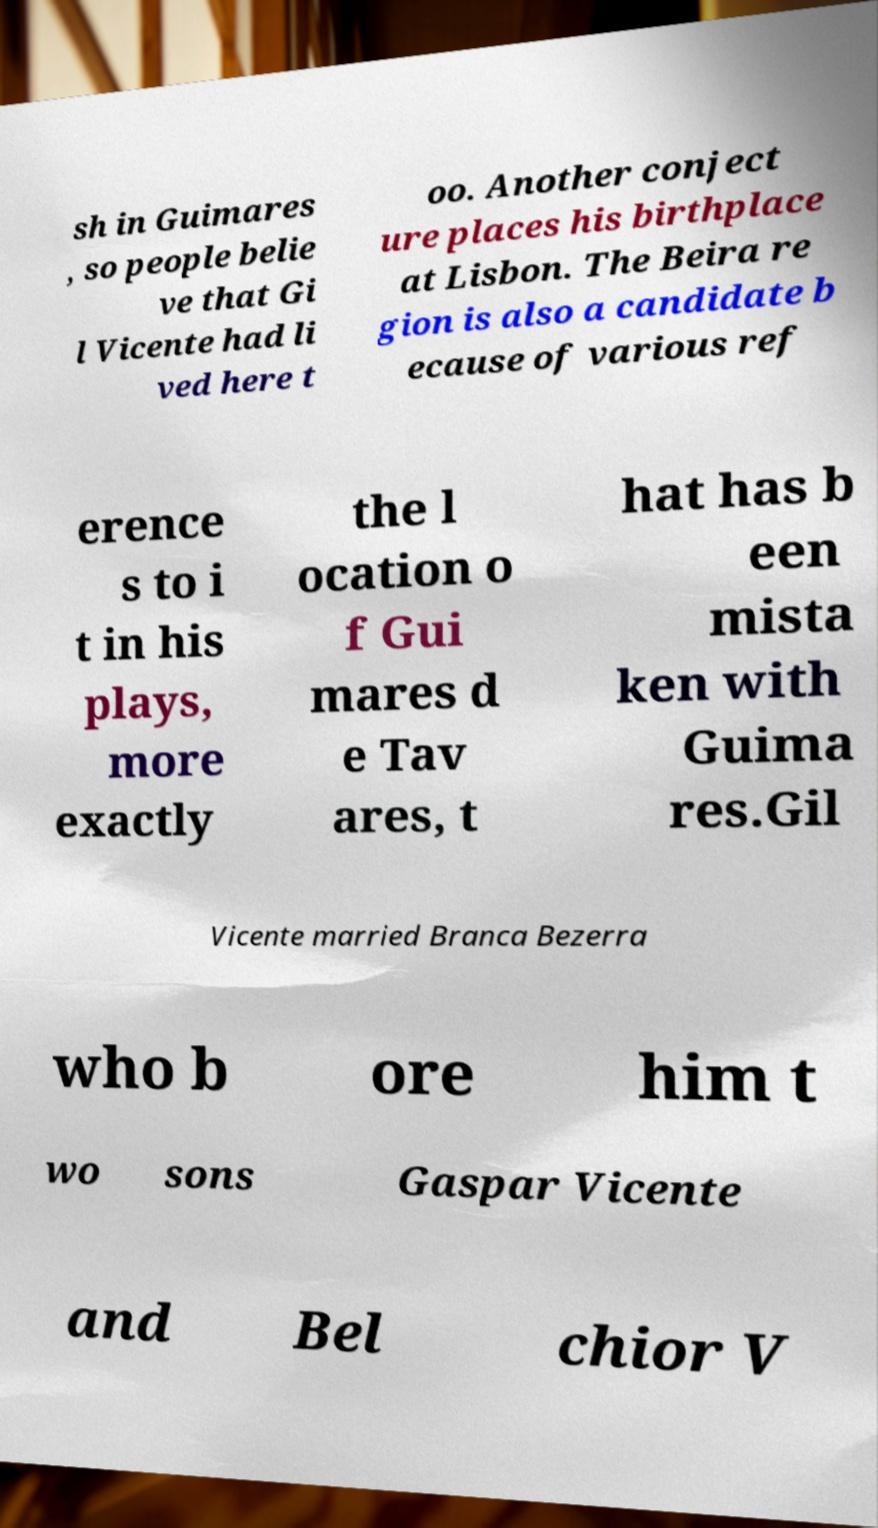What messages or text are displayed in this image? I need them in a readable, typed format. sh in Guimares , so people belie ve that Gi l Vicente had li ved here t oo. Another conject ure places his birthplace at Lisbon. The Beira re gion is also a candidate b ecause of various ref erence s to i t in his plays, more exactly the l ocation o f Gui mares d e Tav ares, t hat has b een mista ken with Guima res.Gil Vicente married Branca Bezerra who b ore him t wo sons Gaspar Vicente and Bel chior V 